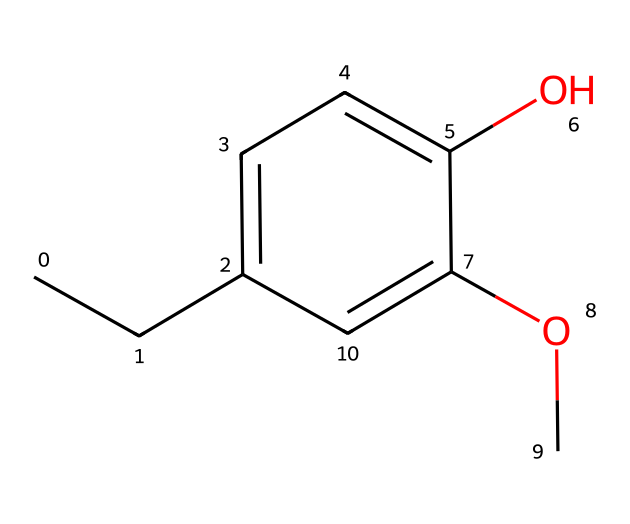How many carbon atoms are in eugenol? The SMILES representation indicates each 'C' stands for a carbon atom. Counting all the 'C's in the structure, we find there are 10 carbon atoms in total.
Answer: 10 What functional groups are present in eugenol? Examining the SMILES structure, there is a hydroxyl group (-OH) and a methoxy group (-OCH3). The presence of these groups identifies them as functional groups in this molecule.
Answer: hydroxyl, methoxy How many hydrogen atoms does eugenol have? To determine the number of hydrogen atoms, we analyze the carbon atoms' connectivity in the structure. The molecular formula derived from the structure (C10H12O3) indicates there are 12 hydrogen atoms in eugenol.
Answer: 12 What is the main phenolic component in clove oil for muscle pain relief? Based on the chemical structure, eugenol is recognized as the primary phenolic component in clove oil known for its analgesic properties.
Answer: eugenol What properties might cause eugenol to relieve muscle pain? The structure of eugenol indicates the presence of both a phenolic hydroxyl group, which can contribute to anti-inflammatory effects, and the aromatic ring, which might enhance its ability to penetrate tissues.
Answer: anti-inflammatory Which aromatic properties can be inferred from the structure of eugenol? The presence of a conjugated double bond system in the aromatic ring suggests eugenol has noticeable aromatic properties, which include fragrance and potential for antioxidant activity.
Answer: aromatic properties 